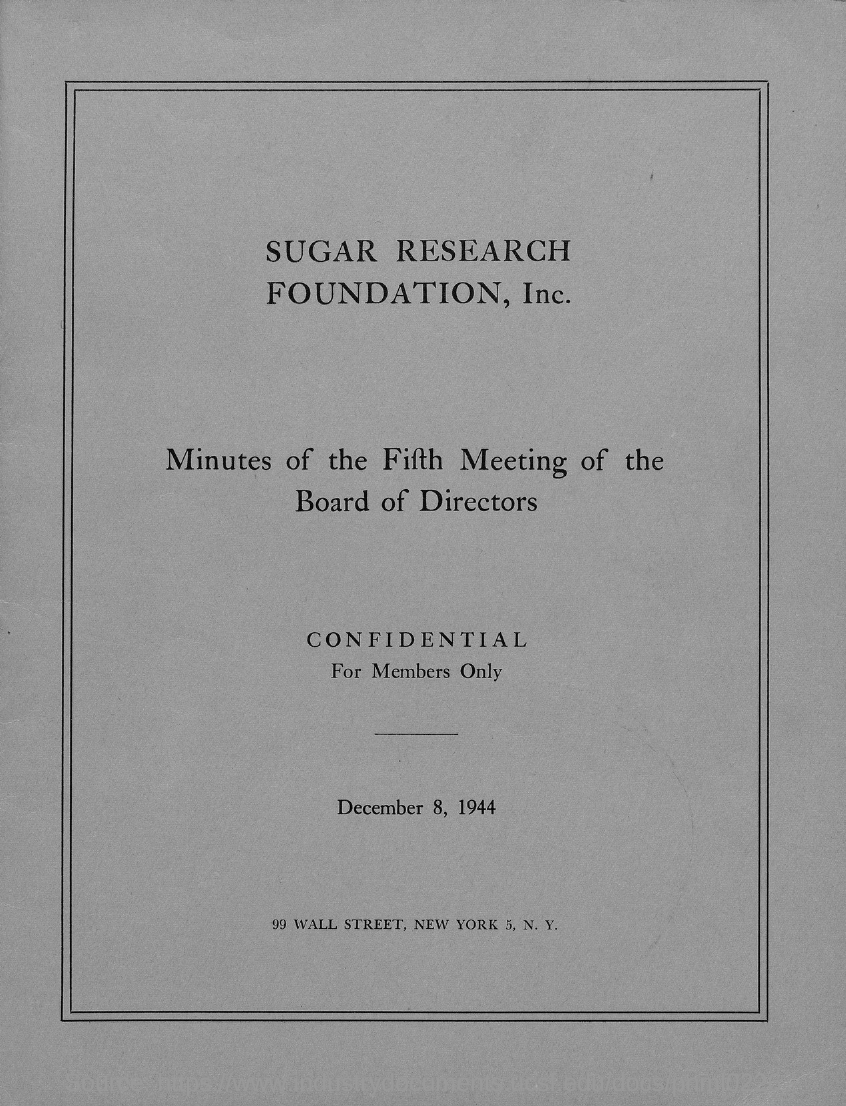Point out several critical features in this image. The document provides the information that the date mentioned is December 8, 1944. The Sugar Research Foundation, Inc., is the research foundation in question. 